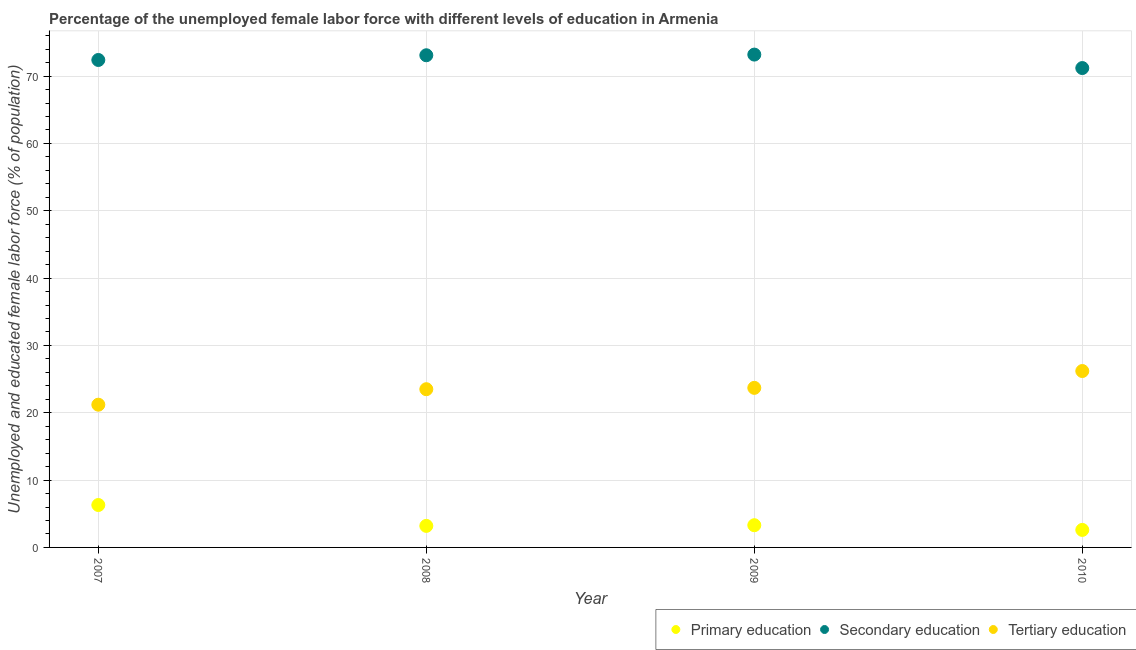Is the number of dotlines equal to the number of legend labels?
Give a very brief answer. Yes. What is the percentage of female labor force who received secondary education in 2008?
Provide a short and direct response. 73.1. Across all years, what is the maximum percentage of female labor force who received secondary education?
Your answer should be very brief. 73.2. Across all years, what is the minimum percentage of female labor force who received primary education?
Make the answer very short. 2.6. In which year was the percentage of female labor force who received primary education maximum?
Provide a short and direct response. 2007. What is the total percentage of female labor force who received primary education in the graph?
Provide a short and direct response. 15.4. What is the difference between the percentage of female labor force who received tertiary education in 2008 and that in 2009?
Keep it short and to the point. -0.2. What is the difference between the percentage of female labor force who received tertiary education in 2007 and the percentage of female labor force who received primary education in 2010?
Your answer should be compact. 18.6. What is the average percentage of female labor force who received tertiary education per year?
Keep it short and to the point. 23.65. In the year 2010, what is the difference between the percentage of female labor force who received secondary education and percentage of female labor force who received tertiary education?
Make the answer very short. 45. What is the ratio of the percentage of female labor force who received tertiary education in 2008 to that in 2009?
Give a very brief answer. 0.99. Is the percentage of female labor force who received secondary education in 2007 less than that in 2009?
Your answer should be very brief. Yes. Is the difference between the percentage of female labor force who received secondary education in 2007 and 2008 greater than the difference between the percentage of female labor force who received tertiary education in 2007 and 2008?
Offer a terse response. Yes. What is the difference between the highest and the second highest percentage of female labor force who received tertiary education?
Offer a very short reply. 2.5. In how many years, is the percentage of female labor force who received secondary education greater than the average percentage of female labor force who received secondary education taken over all years?
Keep it short and to the point. 2. Does the percentage of female labor force who received tertiary education monotonically increase over the years?
Give a very brief answer. Yes. Is the percentage of female labor force who received tertiary education strictly greater than the percentage of female labor force who received secondary education over the years?
Ensure brevity in your answer.  No. Is the percentage of female labor force who received tertiary education strictly less than the percentage of female labor force who received primary education over the years?
Offer a very short reply. No. Does the graph contain any zero values?
Keep it short and to the point. No. How many legend labels are there?
Ensure brevity in your answer.  3. What is the title of the graph?
Provide a succinct answer. Percentage of the unemployed female labor force with different levels of education in Armenia. Does "Natural Gas" appear as one of the legend labels in the graph?
Offer a terse response. No. What is the label or title of the Y-axis?
Your answer should be compact. Unemployed and educated female labor force (% of population). What is the Unemployed and educated female labor force (% of population) in Primary education in 2007?
Make the answer very short. 6.3. What is the Unemployed and educated female labor force (% of population) of Secondary education in 2007?
Make the answer very short. 72.4. What is the Unemployed and educated female labor force (% of population) of Tertiary education in 2007?
Your response must be concise. 21.2. What is the Unemployed and educated female labor force (% of population) in Primary education in 2008?
Your answer should be very brief. 3.2. What is the Unemployed and educated female labor force (% of population) of Secondary education in 2008?
Give a very brief answer. 73.1. What is the Unemployed and educated female labor force (% of population) of Tertiary education in 2008?
Give a very brief answer. 23.5. What is the Unemployed and educated female labor force (% of population) in Primary education in 2009?
Offer a terse response. 3.3. What is the Unemployed and educated female labor force (% of population) of Secondary education in 2009?
Your answer should be very brief. 73.2. What is the Unemployed and educated female labor force (% of population) in Tertiary education in 2009?
Your answer should be compact. 23.7. What is the Unemployed and educated female labor force (% of population) of Primary education in 2010?
Give a very brief answer. 2.6. What is the Unemployed and educated female labor force (% of population) in Secondary education in 2010?
Provide a succinct answer. 71.2. What is the Unemployed and educated female labor force (% of population) in Tertiary education in 2010?
Offer a terse response. 26.2. Across all years, what is the maximum Unemployed and educated female labor force (% of population) in Primary education?
Make the answer very short. 6.3. Across all years, what is the maximum Unemployed and educated female labor force (% of population) of Secondary education?
Keep it short and to the point. 73.2. Across all years, what is the maximum Unemployed and educated female labor force (% of population) in Tertiary education?
Your answer should be compact. 26.2. Across all years, what is the minimum Unemployed and educated female labor force (% of population) of Primary education?
Your response must be concise. 2.6. Across all years, what is the minimum Unemployed and educated female labor force (% of population) in Secondary education?
Your answer should be very brief. 71.2. Across all years, what is the minimum Unemployed and educated female labor force (% of population) of Tertiary education?
Ensure brevity in your answer.  21.2. What is the total Unemployed and educated female labor force (% of population) of Primary education in the graph?
Provide a short and direct response. 15.4. What is the total Unemployed and educated female labor force (% of population) in Secondary education in the graph?
Your answer should be compact. 289.9. What is the total Unemployed and educated female labor force (% of population) in Tertiary education in the graph?
Give a very brief answer. 94.6. What is the difference between the Unemployed and educated female labor force (% of population) in Tertiary education in 2007 and that in 2008?
Offer a terse response. -2.3. What is the difference between the Unemployed and educated female labor force (% of population) of Primary education in 2007 and that in 2009?
Make the answer very short. 3. What is the difference between the Unemployed and educated female labor force (% of population) in Tertiary education in 2007 and that in 2009?
Provide a succinct answer. -2.5. What is the difference between the Unemployed and educated female labor force (% of population) in Primary education in 2007 and that in 2010?
Provide a short and direct response. 3.7. What is the difference between the Unemployed and educated female labor force (% of population) in Secondary education in 2007 and that in 2010?
Provide a succinct answer. 1.2. What is the difference between the Unemployed and educated female labor force (% of population) in Tertiary education in 2007 and that in 2010?
Keep it short and to the point. -5. What is the difference between the Unemployed and educated female labor force (% of population) in Primary education in 2008 and that in 2009?
Offer a very short reply. -0.1. What is the difference between the Unemployed and educated female labor force (% of population) in Secondary education in 2008 and that in 2010?
Provide a short and direct response. 1.9. What is the difference between the Unemployed and educated female labor force (% of population) in Tertiary education in 2008 and that in 2010?
Make the answer very short. -2.7. What is the difference between the Unemployed and educated female labor force (% of population) in Primary education in 2009 and that in 2010?
Provide a short and direct response. 0.7. What is the difference between the Unemployed and educated female labor force (% of population) in Tertiary education in 2009 and that in 2010?
Provide a succinct answer. -2.5. What is the difference between the Unemployed and educated female labor force (% of population) of Primary education in 2007 and the Unemployed and educated female labor force (% of population) of Secondary education in 2008?
Provide a short and direct response. -66.8. What is the difference between the Unemployed and educated female labor force (% of population) in Primary education in 2007 and the Unemployed and educated female labor force (% of population) in Tertiary education in 2008?
Make the answer very short. -17.2. What is the difference between the Unemployed and educated female labor force (% of population) of Secondary education in 2007 and the Unemployed and educated female labor force (% of population) of Tertiary education in 2008?
Make the answer very short. 48.9. What is the difference between the Unemployed and educated female labor force (% of population) in Primary education in 2007 and the Unemployed and educated female labor force (% of population) in Secondary education in 2009?
Your answer should be very brief. -66.9. What is the difference between the Unemployed and educated female labor force (% of population) of Primary education in 2007 and the Unemployed and educated female labor force (% of population) of Tertiary education in 2009?
Ensure brevity in your answer.  -17.4. What is the difference between the Unemployed and educated female labor force (% of population) in Secondary education in 2007 and the Unemployed and educated female labor force (% of population) in Tertiary education in 2009?
Provide a succinct answer. 48.7. What is the difference between the Unemployed and educated female labor force (% of population) of Primary education in 2007 and the Unemployed and educated female labor force (% of population) of Secondary education in 2010?
Ensure brevity in your answer.  -64.9. What is the difference between the Unemployed and educated female labor force (% of population) in Primary education in 2007 and the Unemployed and educated female labor force (% of population) in Tertiary education in 2010?
Give a very brief answer. -19.9. What is the difference between the Unemployed and educated female labor force (% of population) of Secondary education in 2007 and the Unemployed and educated female labor force (% of population) of Tertiary education in 2010?
Offer a terse response. 46.2. What is the difference between the Unemployed and educated female labor force (% of population) in Primary education in 2008 and the Unemployed and educated female labor force (% of population) in Secondary education in 2009?
Your answer should be compact. -70. What is the difference between the Unemployed and educated female labor force (% of population) of Primary education in 2008 and the Unemployed and educated female labor force (% of population) of Tertiary education in 2009?
Offer a terse response. -20.5. What is the difference between the Unemployed and educated female labor force (% of population) of Secondary education in 2008 and the Unemployed and educated female labor force (% of population) of Tertiary education in 2009?
Give a very brief answer. 49.4. What is the difference between the Unemployed and educated female labor force (% of population) in Primary education in 2008 and the Unemployed and educated female labor force (% of population) in Secondary education in 2010?
Your answer should be very brief. -68. What is the difference between the Unemployed and educated female labor force (% of population) in Primary education in 2008 and the Unemployed and educated female labor force (% of population) in Tertiary education in 2010?
Provide a succinct answer. -23. What is the difference between the Unemployed and educated female labor force (% of population) of Secondary education in 2008 and the Unemployed and educated female labor force (% of population) of Tertiary education in 2010?
Give a very brief answer. 46.9. What is the difference between the Unemployed and educated female labor force (% of population) in Primary education in 2009 and the Unemployed and educated female labor force (% of population) in Secondary education in 2010?
Offer a terse response. -67.9. What is the difference between the Unemployed and educated female labor force (% of population) in Primary education in 2009 and the Unemployed and educated female labor force (% of population) in Tertiary education in 2010?
Provide a succinct answer. -22.9. What is the average Unemployed and educated female labor force (% of population) in Primary education per year?
Provide a short and direct response. 3.85. What is the average Unemployed and educated female labor force (% of population) of Secondary education per year?
Your response must be concise. 72.47. What is the average Unemployed and educated female labor force (% of population) of Tertiary education per year?
Make the answer very short. 23.65. In the year 2007, what is the difference between the Unemployed and educated female labor force (% of population) of Primary education and Unemployed and educated female labor force (% of population) of Secondary education?
Offer a terse response. -66.1. In the year 2007, what is the difference between the Unemployed and educated female labor force (% of population) in Primary education and Unemployed and educated female labor force (% of population) in Tertiary education?
Provide a succinct answer. -14.9. In the year 2007, what is the difference between the Unemployed and educated female labor force (% of population) in Secondary education and Unemployed and educated female labor force (% of population) in Tertiary education?
Your response must be concise. 51.2. In the year 2008, what is the difference between the Unemployed and educated female labor force (% of population) of Primary education and Unemployed and educated female labor force (% of population) of Secondary education?
Provide a succinct answer. -69.9. In the year 2008, what is the difference between the Unemployed and educated female labor force (% of population) of Primary education and Unemployed and educated female labor force (% of population) of Tertiary education?
Provide a short and direct response. -20.3. In the year 2008, what is the difference between the Unemployed and educated female labor force (% of population) in Secondary education and Unemployed and educated female labor force (% of population) in Tertiary education?
Make the answer very short. 49.6. In the year 2009, what is the difference between the Unemployed and educated female labor force (% of population) of Primary education and Unemployed and educated female labor force (% of population) of Secondary education?
Ensure brevity in your answer.  -69.9. In the year 2009, what is the difference between the Unemployed and educated female labor force (% of population) in Primary education and Unemployed and educated female labor force (% of population) in Tertiary education?
Your answer should be compact. -20.4. In the year 2009, what is the difference between the Unemployed and educated female labor force (% of population) of Secondary education and Unemployed and educated female labor force (% of population) of Tertiary education?
Keep it short and to the point. 49.5. In the year 2010, what is the difference between the Unemployed and educated female labor force (% of population) in Primary education and Unemployed and educated female labor force (% of population) in Secondary education?
Provide a succinct answer. -68.6. In the year 2010, what is the difference between the Unemployed and educated female labor force (% of population) of Primary education and Unemployed and educated female labor force (% of population) of Tertiary education?
Your answer should be very brief. -23.6. What is the ratio of the Unemployed and educated female labor force (% of population) in Primary education in 2007 to that in 2008?
Your answer should be very brief. 1.97. What is the ratio of the Unemployed and educated female labor force (% of population) in Tertiary education in 2007 to that in 2008?
Offer a very short reply. 0.9. What is the ratio of the Unemployed and educated female labor force (% of population) of Primary education in 2007 to that in 2009?
Your response must be concise. 1.91. What is the ratio of the Unemployed and educated female labor force (% of population) in Secondary education in 2007 to that in 2009?
Give a very brief answer. 0.99. What is the ratio of the Unemployed and educated female labor force (% of population) in Tertiary education in 2007 to that in 2009?
Give a very brief answer. 0.89. What is the ratio of the Unemployed and educated female labor force (% of population) in Primary education in 2007 to that in 2010?
Provide a short and direct response. 2.42. What is the ratio of the Unemployed and educated female labor force (% of population) in Secondary education in 2007 to that in 2010?
Your answer should be very brief. 1.02. What is the ratio of the Unemployed and educated female labor force (% of population) in Tertiary education in 2007 to that in 2010?
Keep it short and to the point. 0.81. What is the ratio of the Unemployed and educated female labor force (% of population) of Primary education in 2008 to that in 2009?
Your answer should be very brief. 0.97. What is the ratio of the Unemployed and educated female labor force (% of population) of Tertiary education in 2008 to that in 2009?
Your response must be concise. 0.99. What is the ratio of the Unemployed and educated female labor force (% of population) of Primary education in 2008 to that in 2010?
Your response must be concise. 1.23. What is the ratio of the Unemployed and educated female labor force (% of population) in Secondary education in 2008 to that in 2010?
Your answer should be compact. 1.03. What is the ratio of the Unemployed and educated female labor force (% of population) of Tertiary education in 2008 to that in 2010?
Ensure brevity in your answer.  0.9. What is the ratio of the Unemployed and educated female labor force (% of population) in Primary education in 2009 to that in 2010?
Your answer should be very brief. 1.27. What is the ratio of the Unemployed and educated female labor force (% of population) of Secondary education in 2009 to that in 2010?
Offer a terse response. 1.03. What is the ratio of the Unemployed and educated female labor force (% of population) of Tertiary education in 2009 to that in 2010?
Your answer should be very brief. 0.9. What is the difference between the highest and the second highest Unemployed and educated female labor force (% of population) of Secondary education?
Provide a succinct answer. 0.1. What is the difference between the highest and the lowest Unemployed and educated female labor force (% of population) of Secondary education?
Your answer should be compact. 2. 